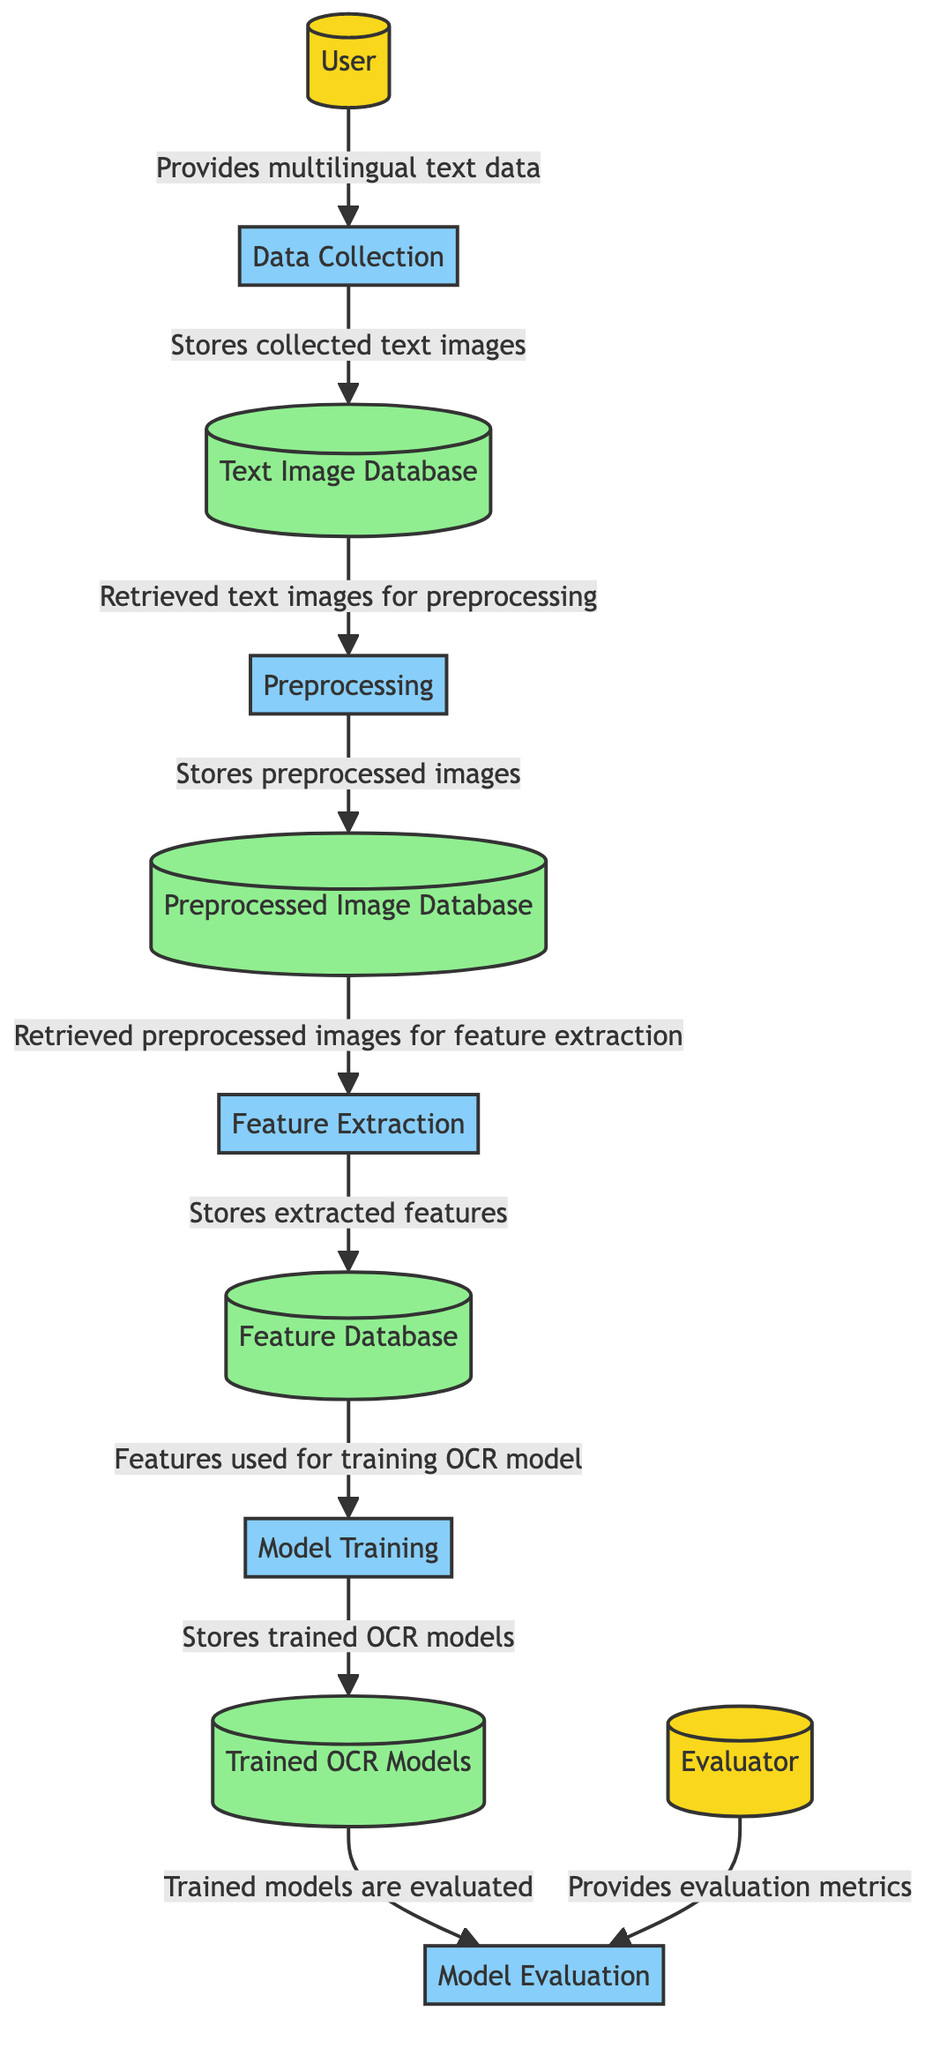What is the first process in the diagram? The first process in the diagram is "Data Collection," which is the second element in the flow. This process follows the "User" external entity that provides multilingual text data for training.
Answer: Data Collection How many data stores are present in the diagram? The diagram contains four data stores: "Text Image Database," "Preprocessed Image Database," "Feature Database," and "Trained OCR Models." Counting these reveals the total number of data stores.
Answer: Four What type of entity provides evaluation metrics? The entity that provides evaluation metrics is the "Evaluator," which is an external entity in the diagram. This is indicated in the last connection leading to the "Model Evaluation" process.
Answer: Evaluator Which process follows preprocessing in the data flow? The process that follows "Preprocessing" in the data flow is "Feature Extraction." This can be validated by tracing the arrows that indicate flows from "Preprocessing" to "Feature Extraction."
Answer: Feature Extraction What is stored in the "Feature Database"? The "Feature Database" stores the extracted features that have been obtained from the preprocessed images. This can be identified by reviewing the connection leading to "Feature Database" from "Feature Extraction."
Answer: Extracted features How are the trained models evaluated? The trained models are evaluated by the "Model Evaluation" process, which takes the "Trained OCR Models" as input. This relationship is established with a directed flow from "Trained OCR Models" to "Model Evaluation."
Answer: Model Evaluation What retrieves text images for preprocessing? "Text Image Database" retrieves text images for preprocessing. This is indicated by the flow from the "Text Image Database" to the "Preprocessing" process in the diagram.
Answer: Text Image Database What is the last process in the diagram? The last process in the diagram is "Model Evaluation," which is the tenth element. The diagram ends with this process following the flow from "Trained OCR Models."
Answer: Model Evaluation Which process uses features for OCR model training? The process that uses features for OCR model training is "Model Training." This can be confirmed by checking the flow coming from "Feature Database" to "Model Training."
Answer: Model Training 